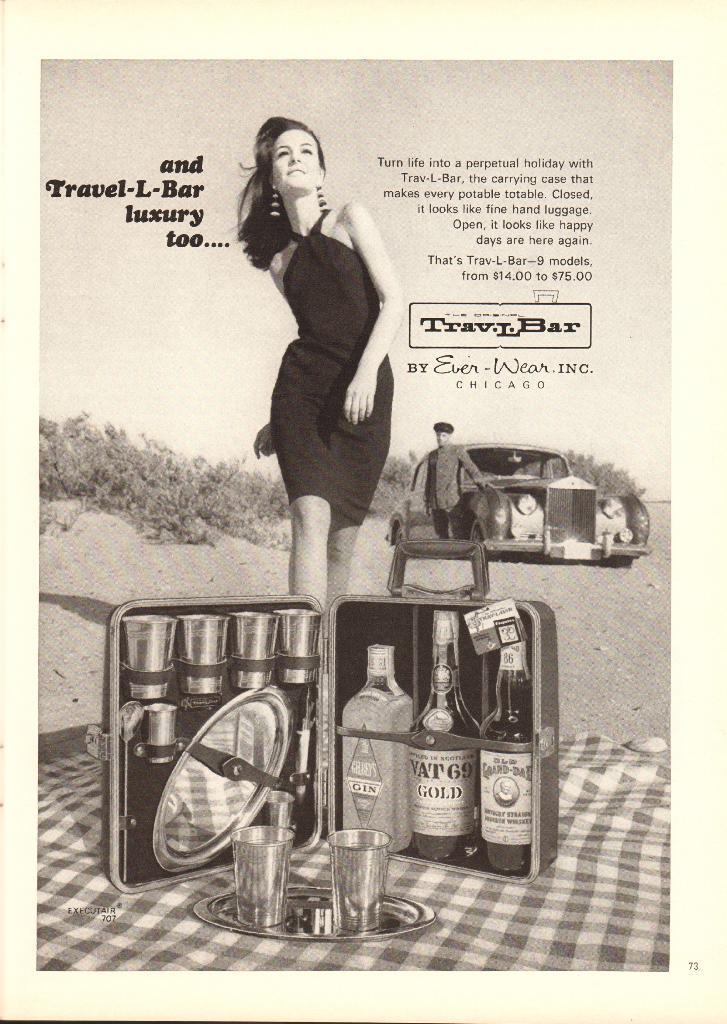Describe this image in one or two sentences. This is a poster. In this picture we can see a woman. There are few bottles, glasses, plate in a suitcase. We can see two glasses in a plate and a cloth. We can see a person, car and few plants are visible in the background. 